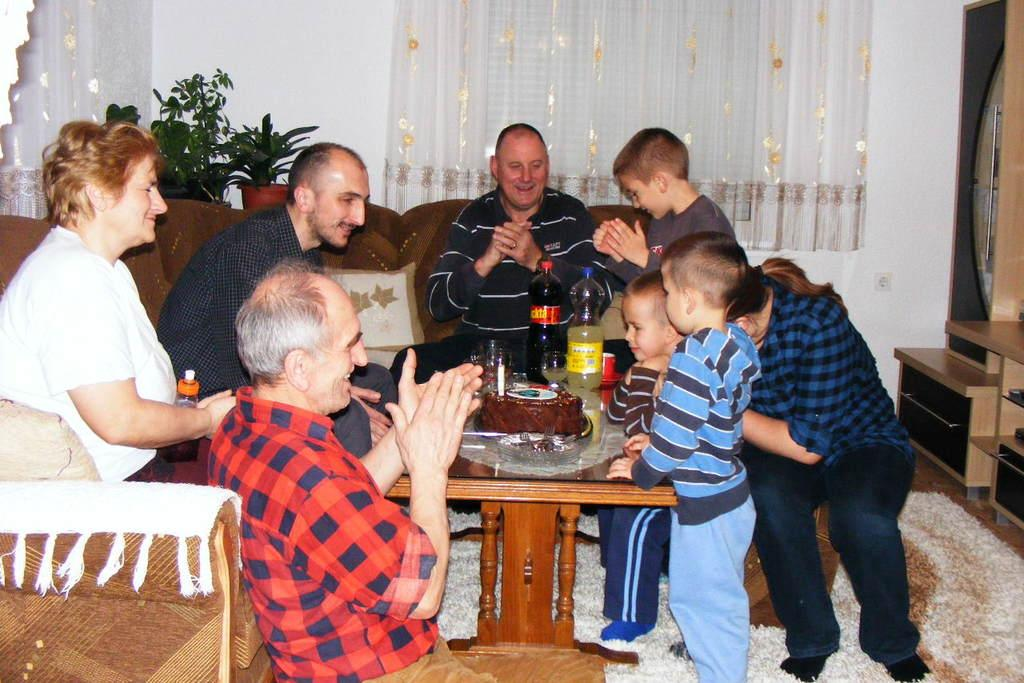How many people are in the image? There are people in the image, but the exact number is not specified. What positions are the people in? Some people are sitting on a sofa, some are sitting on the floor, and some are standing. Can you describe the arrangement of the people in the image? The people are either sitting or standing, with some on the sofa and others on the floor. What type of yam is being discussed by the people in the image? There is no mention of a yam or any discussion in the image. Can you describe the spark between the people sitting on the sofa? There is no spark or any indication of a spark between the people in the image. 